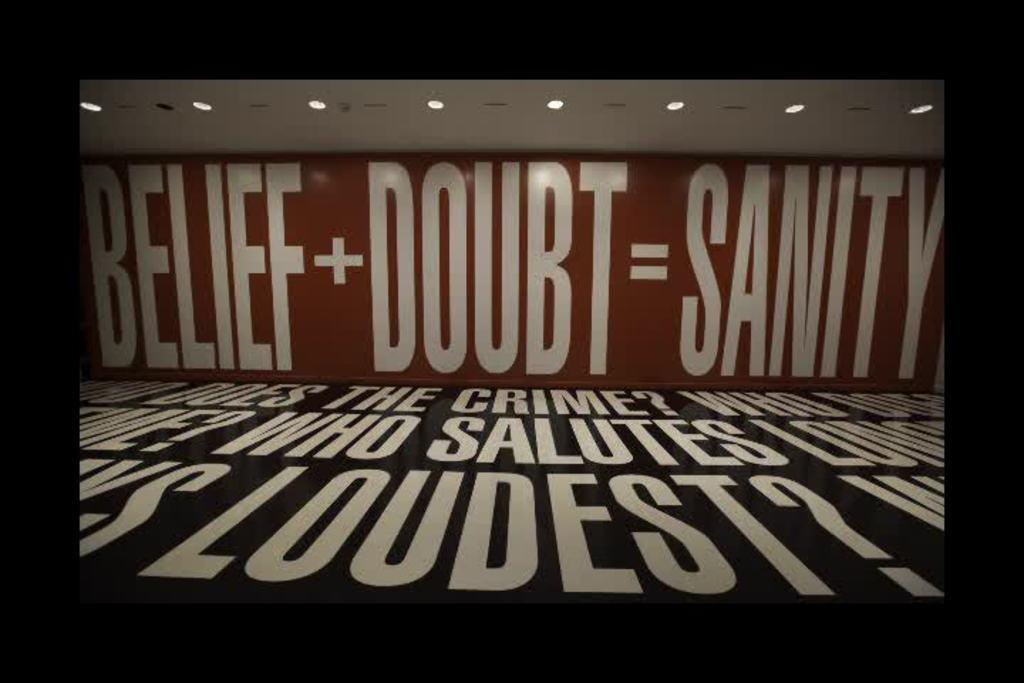<image>
Summarize the visual content of the image. Belief + Doubt = Sanity is written on a wall 